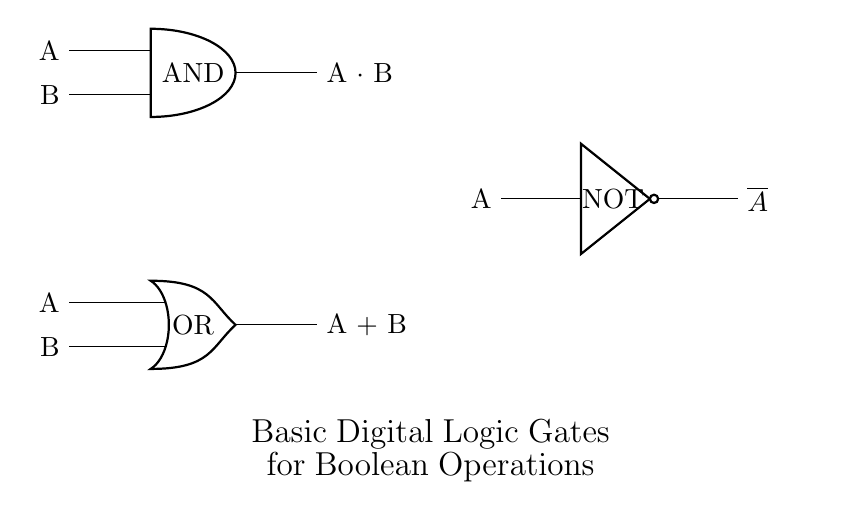What type of logic gate is shown at the top? The top section of the circuit diagram displays an AND logic gate, which has two input lines labeled A and B. This gate produces an output only when both inputs are true (high voltage).
Answer: AND What is the output expression for the OR gate? The OR gate at the bottom has inputs A and B leading to an output that is true if at least one of the inputs is true. The output expression can be represented as A plus B.
Answer: A plus B How many logic gates are present in the circuit? There are three distinct logic gates arranged vertically: one AND gate, one OR gate, and one NOT gate. Each gate performs a different basic operation in digital logic.
Answer: Three What operation does the NOT gate perform? The NOT gate is designed to invert its single input. In this diagram, it takes input A and produces an output that is the logical negation, indicated as not A.
Answer: Not A What are the labels for the inputs of the AND gate? The AND gate has two input labels, both of which are represented clearly in the circuit diagram. The labels indicate the variables that correspond to the inputs at the gate.
Answer: A, B What is the output label of the NOT gate? The NOT gate produces an output that is specifically the negation of its input A. In the diagram, this is denoted by the symbol for negation (overline) preceding A, indicating its output.
Answer: Not A 